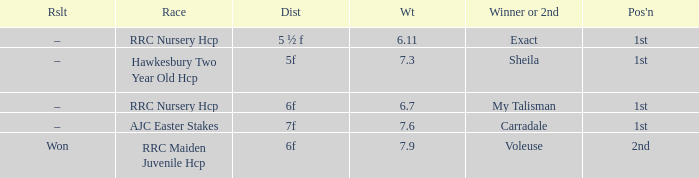What was the race when the winner of 2nd was Voleuse? RRC Maiden Juvenile Hcp. 